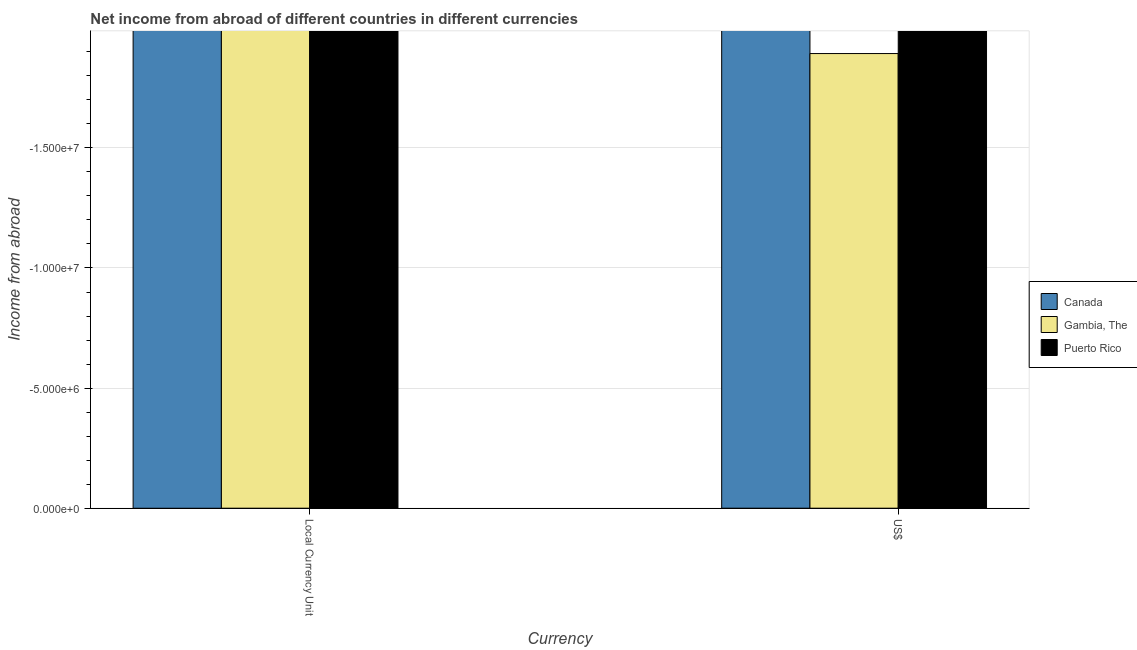How many different coloured bars are there?
Your response must be concise. 0. Are the number of bars per tick equal to the number of legend labels?
Provide a succinct answer. No. Are the number of bars on each tick of the X-axis equal?
Offer a very short reply. Yes. What is the label of the 1st group of bars from the left?
Offer a terse response. Local Currency Unit. Across all countries, what is the minimum income from abroad in constant 2005 us$?
Provide a short and direct response. 0. What is the difference between the income from abroad in us$ in Puerto Rico and the income from abroad in constant 2005 us$ in Canada?
Your answer should be very brief. 0. What is the average income from abroad in constant 2005 us$ per country?
Your answer should be compact. 0. In how many countries, is the income from abroad in constant 2005 us$ greater than the average income from abroad in constant 2005 us$ taken over all countries?
Provide a succinct answer. 0. How many bars are there?
Make the answer very short. 0. What is the difference between two consecutive major ticks on the Y-axis?
Give a very brief answer. 5.00e+06. Are the values on the major ticks of Y-axis written in scientific E-notation?
Give a very brief answer. Yes. Where does the legend appear in the graph?
Offer a terse response. Center right. How many legend labels are there?
Provide a succinct answer. 3. How are the legend labels stacked?
Your response must be concise. Vertical. What is the title of the graph?
Your answer should be very brief. Net income from abroad of different countries in different currencies. Does "Netherlands" appear as one of the legend labels in the graph?
Provide a short and direct response. No. What is the label or title of the X-axis?
Your response must be concise. Currency. What is the label or title of the Y-axis?
Offer a terse response. Income from abroad. What is the Income from abroad in Canada in Local Currency Unit?
Provide a short and direct response. 0. What is the Income from abroad in Canada in US$?
Offer a very short reply. 0. What is the Income from abroad in Gambia, The in US$?
Give a very brief answer. 0. What is the total Income from abroad in Canada in the graph?
Give a very brief answer. 0. What is the total Income from abroad in Gambia, The in the graph?
Your response must be concise. 0. What is the average Income from abroad in Canada per Currency?
Keep it short and to the point. 0. 